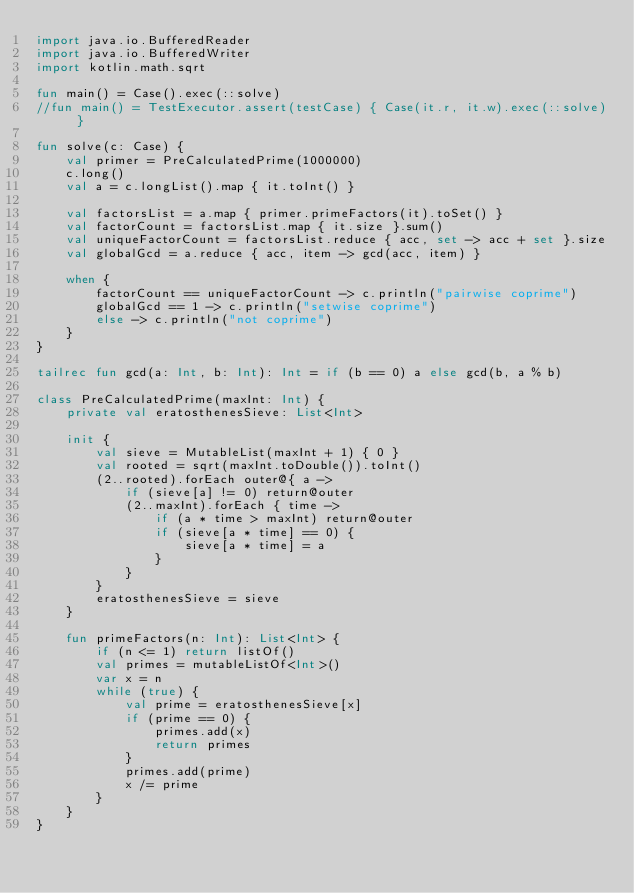Convert code to text. <code><loc_0><loc_0><loc_500><loc_500><_Kotlin_>import java.io.BufferedReader
import java.io.BufferedWriter
import kotlin.math.sqrt

fun main() = Case().exec(::solve)
//fun main() = TestExecutor.assert(testCase) { Case(it.r, it.w).exec(::solve) }

fun solve(c: Case) {
    val primer = PreCalculatedPrime(1000000)
    c.long()
    val a = c.longList().map { it.toInt() }

    val factorsList = a.map { primer.primeFactors(it).toSet() }
    val factorCount = factorsList.map { it.size }.sum()
    val uniqueFactorCount = factorsList.reduce { acc, set -> acc + set }.size
    val globalGcd = a.reduce { acc, item -> gcd(acc, item) }

    when {
        factorCount == uniqueFactorCount -> c.println("pairwise coprime")
        globalGcd == 1 -> c.println("setwise coprime")
        else -> c.println("not coprime")
    }
}

tailrec fun gcd(a: Int, b: Int): Int = if (b == 0) a else gcd(b, a % b)

class PreCalculatedPrime(maxInt: Int) {
    private val eratosthenesSieve: List<Int>

    init {
        val sieve = MutableList(maxInt + 1) { 0 }
        val rooted = sqrt(maxInt.toDouble()).toInt()
        (2..rooted).forEach outer@{ a ->
            if (sieve[a] != 0) return@outer
            (2..maxInt).forEach { time ->
                if (a * time > maxInt) return@outer
                if (sieve[a * time] == 0) {
                    sieve[a * time] = a
                }
            }
        }
        eratosthenesSieve = sieve
    }

    fun primeFactors(n: Int): List<Int> {
        if (n <= 1) return listOf()
        val primes = mutableListOf<Int>()
        var x = n
        while (true) {
            val prime = eratosthenesSieve[x]
            if (prime == 0) {
                primes.add(x)
                return primes
            }
            primes.add(prime)
            x /= prime
        }
    }
}
</code> 